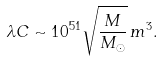<formula> <loc_0><loc_0><loc_500><loc_500>\lambda C \sim 1 0 ^ { 5 1 } \sqrt { \frac { M } { M _ { \odot } } } \, m ^ { 3 } .</formula> 